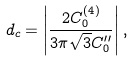<formula> <loc_0><loc_0><loc_500><loc_500>d _ { c } = \left | \frac { 2 C ^ { ( 4 ) } _ { 0 } } { 3 \pi \sqrt { 3 } C ^ { \prime \prime } _ { 0 } } \right | ,</formula> 